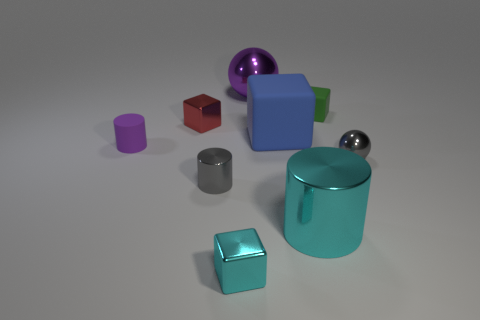Subtract all gray metallic cylinders. How many cylinders are left? 2 Subtract all blue cubes. How many cubes are left? 3 Subtract 2 spheres. How many spheres are left? 0 Subtract all cubes. How many objects are left? 5 Subtract all purple blocks. How many purple spheres are left? 1 Subtract all blue blocks. Subtract all purple metallic spheres. How many objects are left? 7 Add 7 large metallic balls. How many large metallic balls are left? 8 Add 9 large blue cubes. How many large blue cubes exist? 10 Subtract 0 brown cylinders. How many objects are left? 9 Subtract all blue cubes. Subtract all gray spheres. How many cubes are left? 3 